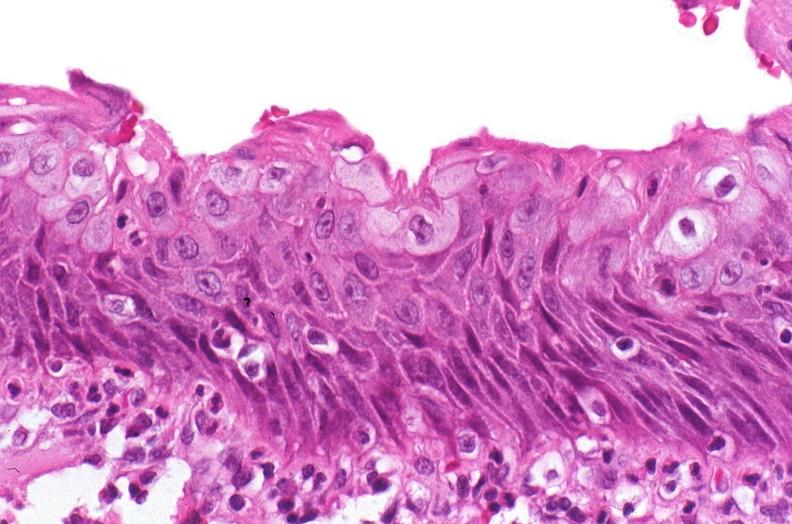s spinal column present?
Answer the question using a single word or phrase. No 